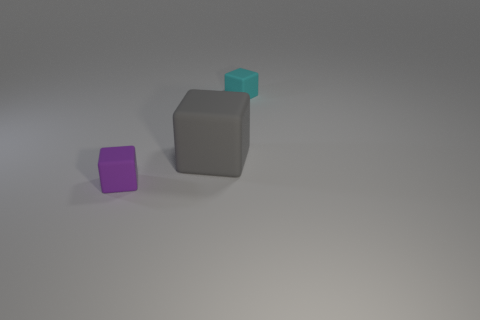Are there any small blue metal things of the same shape as the purple object?
Make the answer very short. No. Does the large thing have the same color as the tiny thing behind the purple block?
Provide a succinct answer. No. Is there a rubber cube of the same size as the purple thing?
Keep it short and to the point. Yes. Is the material of the purple block the same as the small thing behind the gray block?
Offer a very short reply. Yes. Is the number of large gray cubes greater than the number of large yellow matte cylinders?
Your answer should be compact. Yes. What number of blocks are gray things or matte things?
Provide a succinct answer. 3. What is the color of the big thing?
Provide a short and direct response. Gray. There is a cube in front of the gray rubber thing; is it the same size as the cyan matte object that is behind the big gray cube?
Give a very brief answer. Yes. Are there fewer gray rubber cubes than green matte cubes?
Your answer should be very brief. No. There is a gray block; what number of gray blocks are behind it?
Give a very brief answer. 0. 